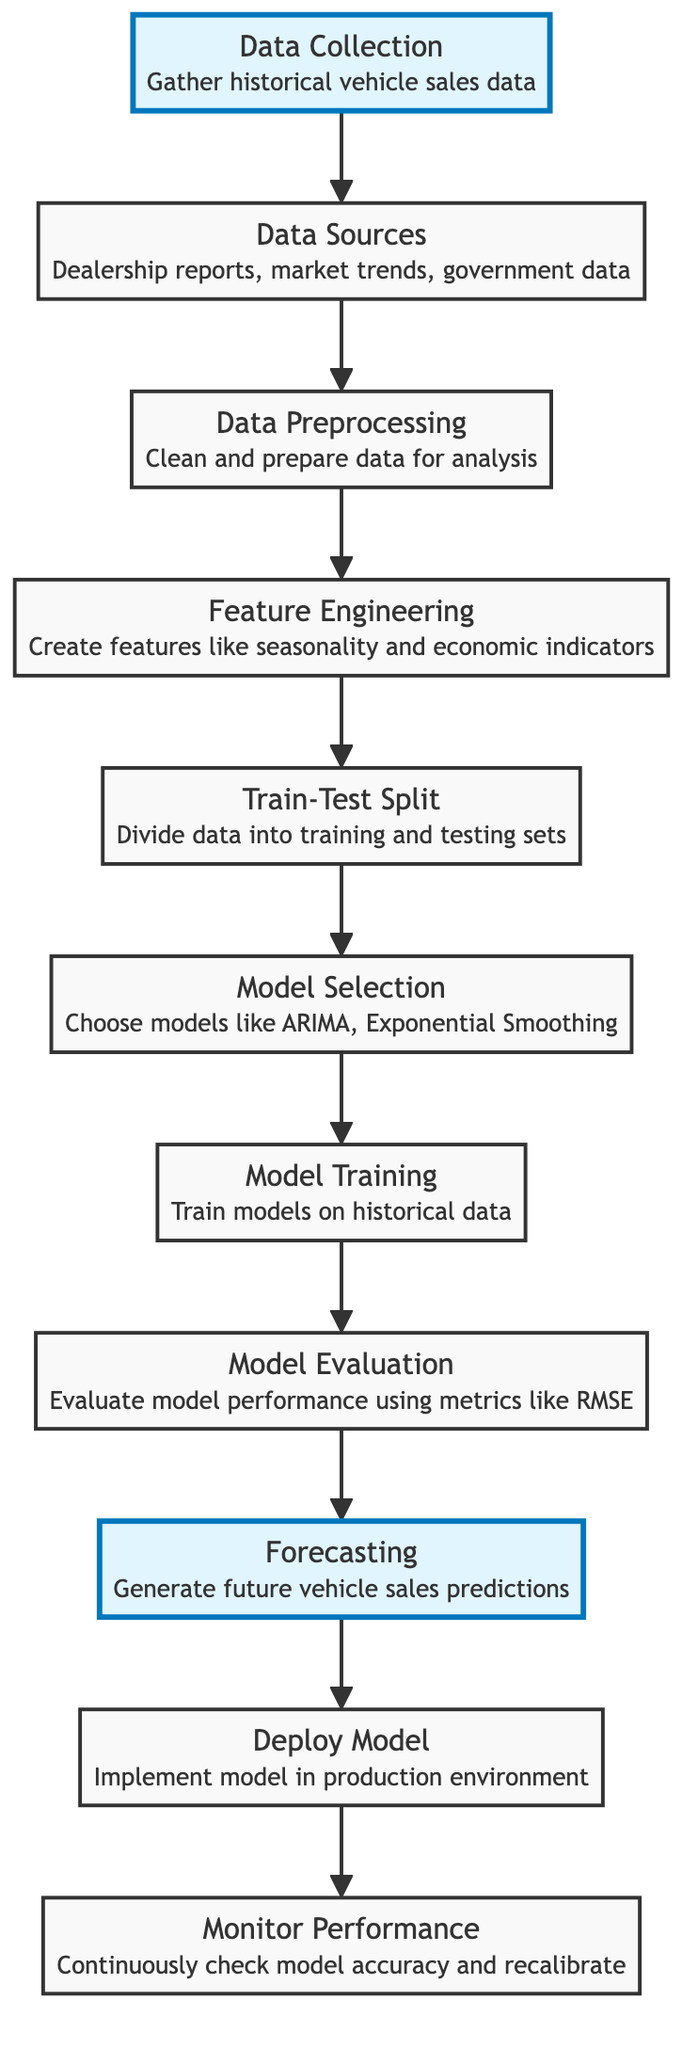What is the first step in the diagram? The diagram shows 'Data Collection' as the first step, which indicates the initial activity to gather historical vehicle sales data.
Answer: Data Collection How many main processing steps are there in the diagram? Counting the nodes between 'Data Collection' and 'Monitor Performance', there are a total of 9 main steps involved in the process.
Answer: Nine What are the main data sources mentioned in the diagram? The diagram lists 'Dealership reports', 'Market trends', and 'Government data' as the main data sources for 'Data Sources'.
Answer: Dealership reports, market trends, government data At which point do we split the data into training and testing sets? The 'Train-Test Split' node represents the step where the data is divided into training and testing sets, occurring after data preprocessing.
Answer: Train-Test Split Which step comes after model evaluation? Looking at the flow from 'Model Evaluation', the next step indicated in the diagram is 'Forecasting', where future vehicle sales predictions are generated.
Answer: Forecasting What type of models are selected in the model selection step? In the step labeled 'Model Selection', the diagram mentions choosing models like ARIMA and Exponential Smoothing, which are specific types of time series forecasting models.
Answer: ARIMA, Exponential Smoothing What phase follows the deployment of the model? After 'Deploy Model', the next phase indicated in the diagram is 'Monitor Performance', which involves continuously checking the accuracy of the implemented model.
Answer: Monitor Performance What is the primary purpose of feature engineering in this diagram? The 'Feature Engineering' step aims to create relevant features such as seasonality and economic indicators that can enhance the predictive power of the chosen models.
Answer: Create features like seasonality and economic indicators How do we ensure the model's accuracy after deployment? The diagram states that 'Monitor Performance' is the phase where we continuously check model accuracy and recalibrate it as necessary to maintain its effectiveness.
Answer: Continuously check model accuracy and recalibrate 